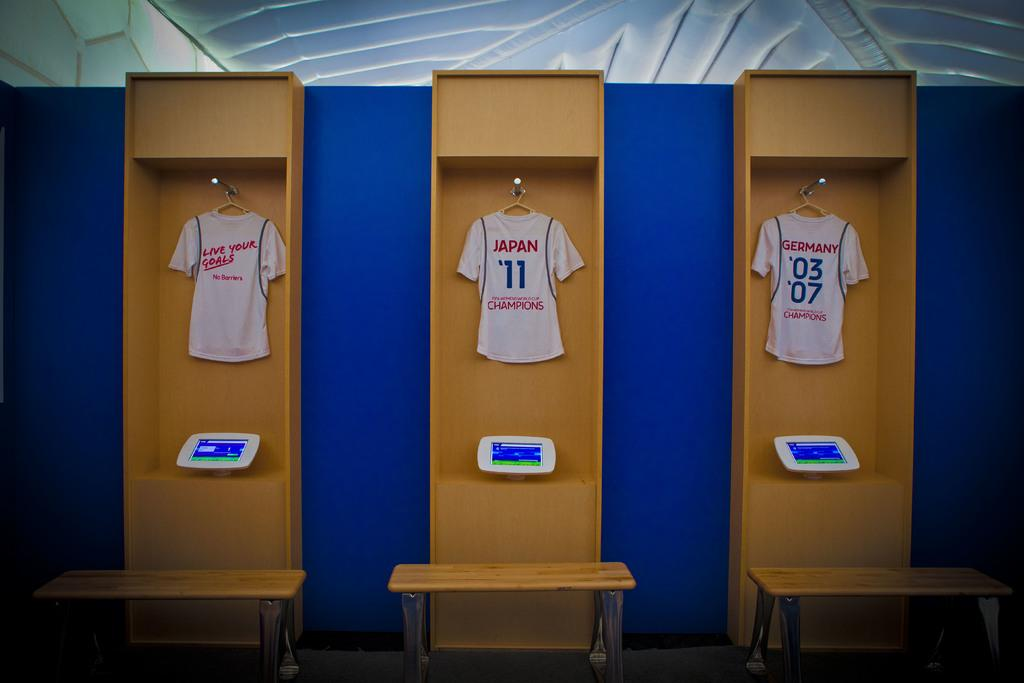Provide a one-sentence caption for the provided image. three jerseys are jung up from different countries. 